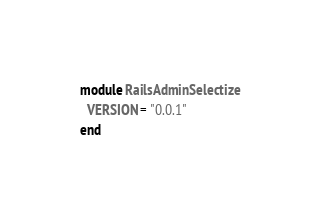Convert code to text. <code><loc_0><loc_0><loc_500><loc_500><_Ruby_>module RailsAdminSelectize
  VERSION = "0.0.1"
end
</code> 